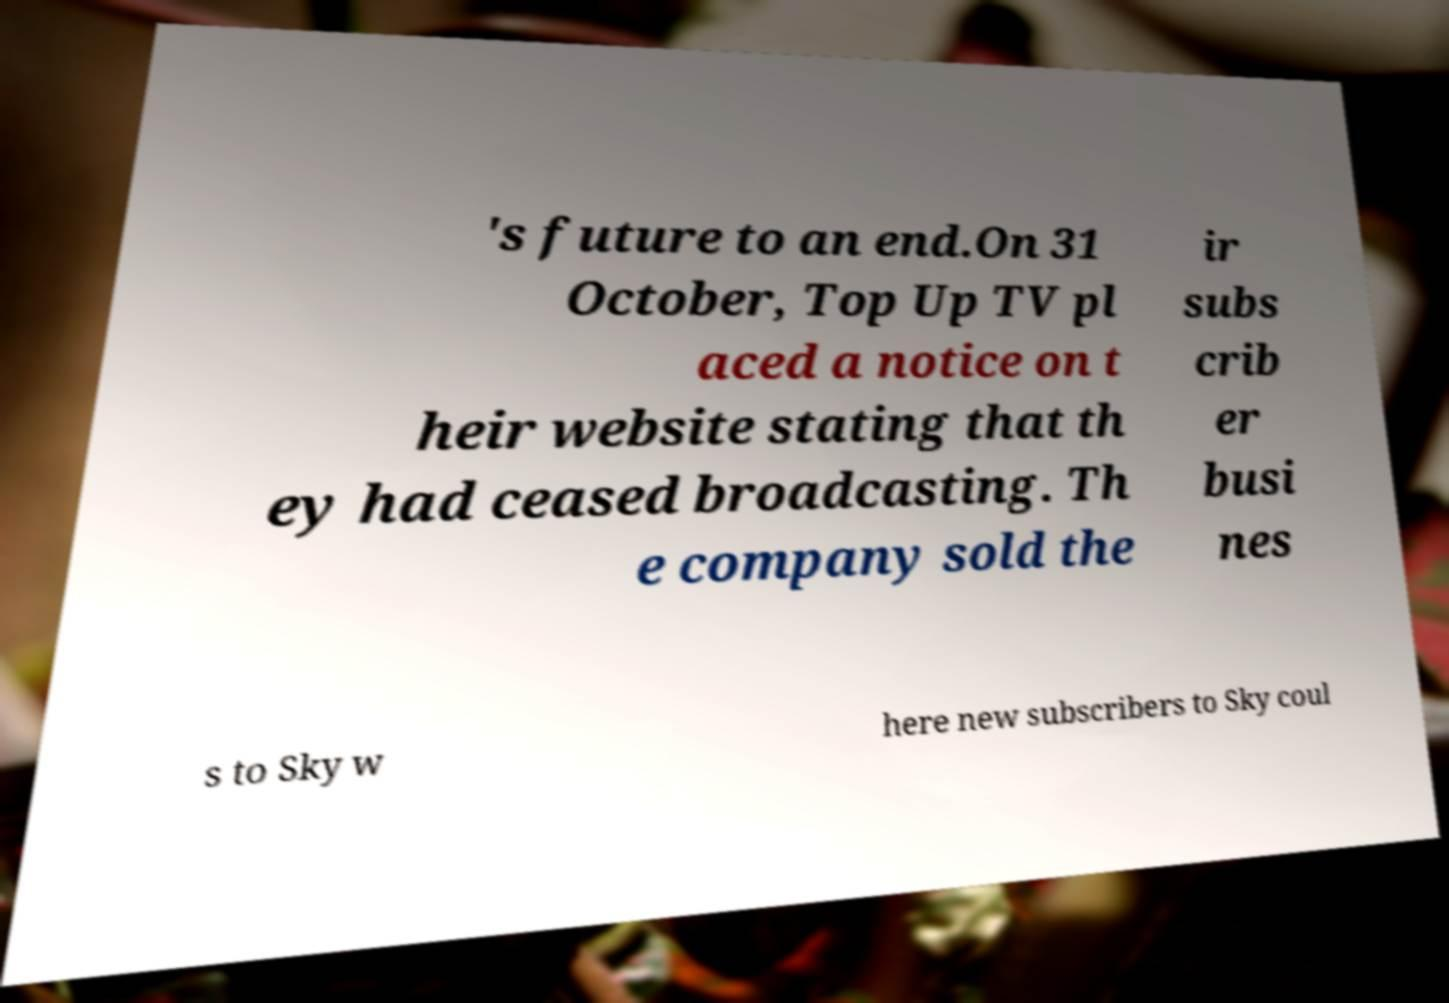Could you extract and type out the text from this image? 's future to an end.On 31 October, Top Up TV pl aced a notice on t heir website stating that th ey had ceased broadcasting. Th e company sold the ir subs crib er busi nes s to Sky w here new subscribers to Sky coul 